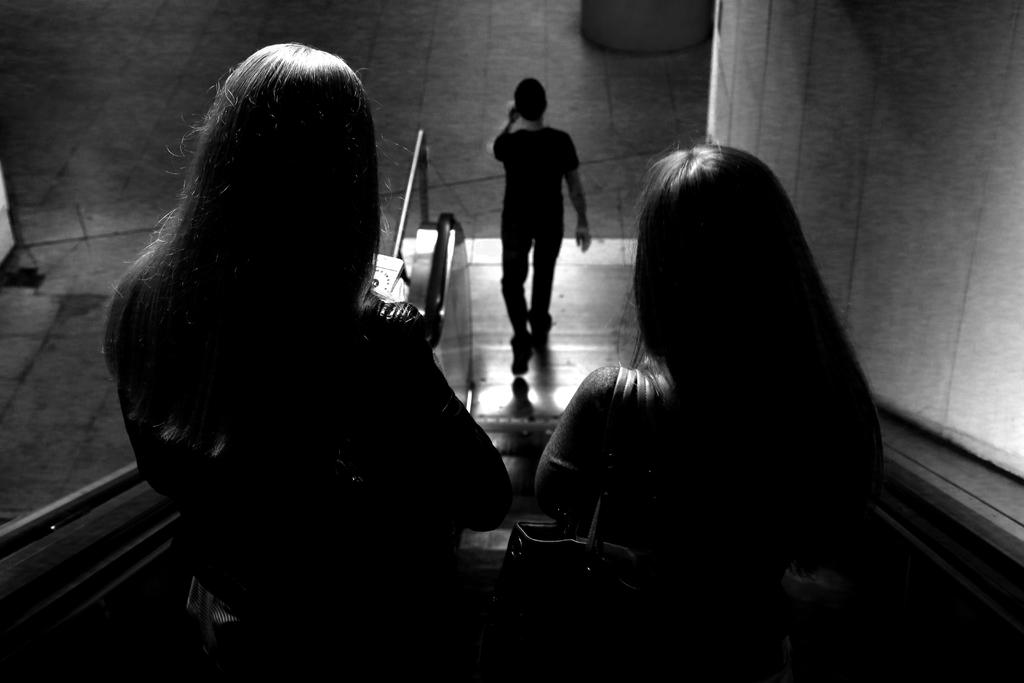What are the two people in the image doing? The two people in the image are standing on the escalator. Can you describe the gender of one of the people in the image? There is a man in the image. What can be seen in the background of the image? There is a wall visible in the image. What type of bone is the dog chewing on in the image? There is no dog or bone present in the image. How does the wealth of the people in the image compare to each other? The provided facts do not give any information about the wealth of the people in the image. 